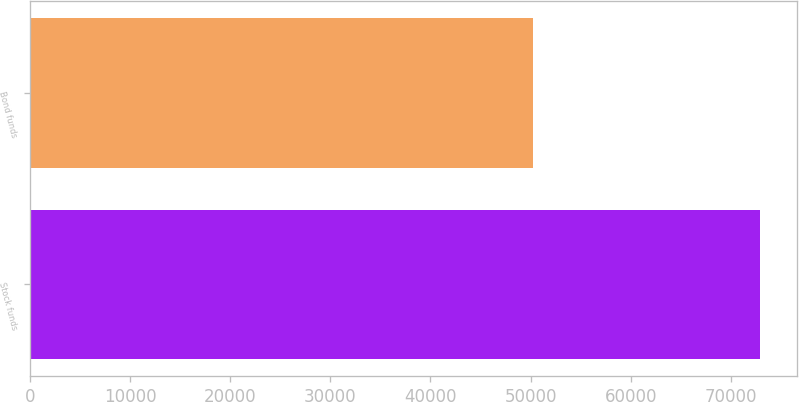Convert chart to OTSL. <chart><loc_0><loc_0><loc_500><loc_500><bar_chart><fcel>Stock funds<fcel>Bond funds<nl><fcel>72929<fcel>50243<nl></chart> 